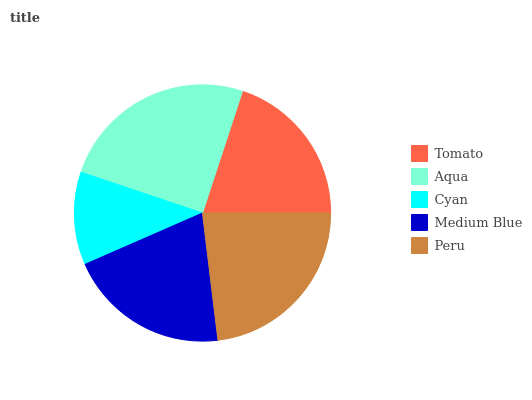Is Cyan the minimum?
Answer yes or no. Yes. Is Aqua the maximum?
Answer yes or no. Yes. Is Aqua the minimum?
Answer yes or no. No. Is Cyan the maximum?
Answer yes or no. No. Is Aqua greater than Cyan?
Answer yes or no. Yes. Is Cyan less than Aqua?
Answer yes or no. Yes. Is Cyan greater than Aqua?
Answer yes or no. No. Is Aqua less than Cyan?
Answer yes or no. No. Is Medium Blue the high median?
Answer yes or no. Yes. Is Medium Blue the low median?
Answer yes or no. Yes. Is Peru the high median?
Answer yes or no. No. Is Cyan the low median?
Answer yes or no. No. 